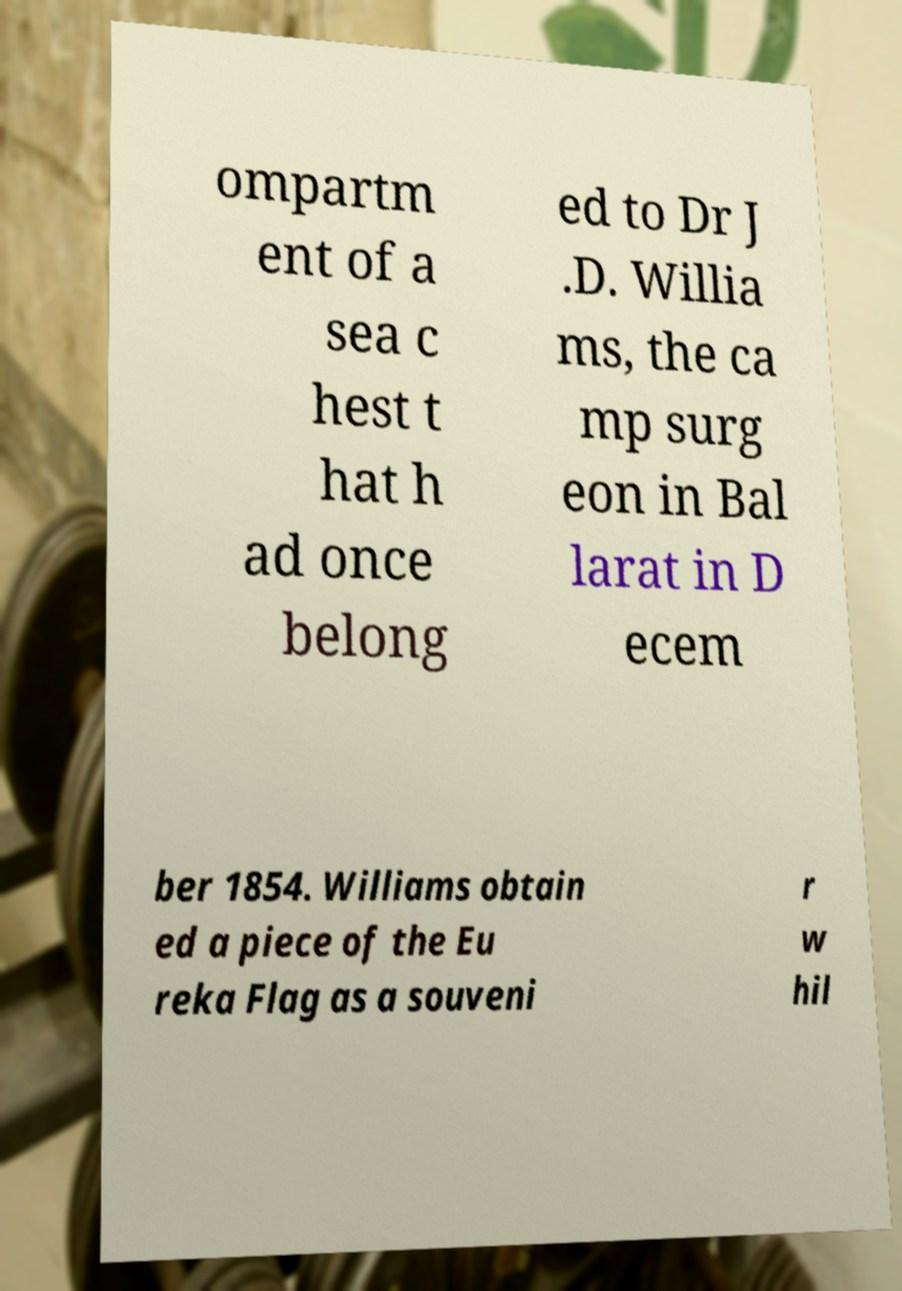Please read and relay the text visible in this image. What does it say? ompartm ent of a sea c hest t hat h ad once belong ed to Dr J .D. Willia ms, the ca mp surg eon in Bal larat in D ecem ber 1854. Williams obtain ed a piece of the Eu reka Flag as a souveni r w hil 